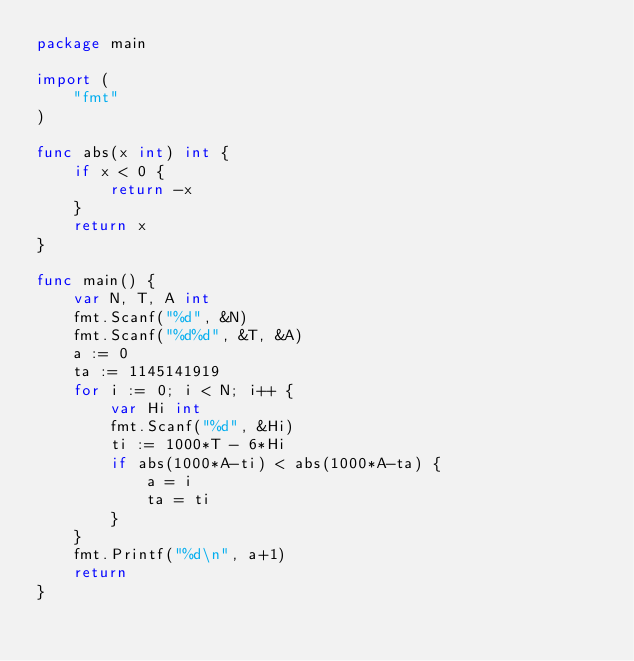Convert code to text. <code><loc_0><loc_0><loc_500><loc_500><_Go_>package main

import (
	"fmt"
)

func abs(x int) int {
	if x < 0 {
		return -x
	}
	return x
}

func main() {
	var N, T, A int
	fmt.Scanf("%d", &N)
	fmt.Scanf("%d%d", &T, &A)
	a := 0
	ta := 1145141919
	for i := 0; i < N; i++ {
		var Hi int
		fmt.Scanf("%d", &Hi)
		ti := 1000*T - 6*Hi
		if abs(1000*A-ti) < abs(1000*A-ta) {
			a = i
			ta = ti
		}
	}
	fmt.Printf("%d\n", a+1)
	return
}
</code> 